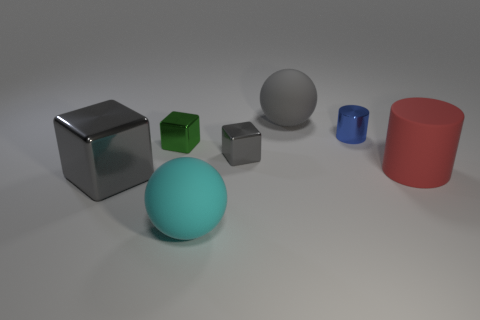Subtract all big cubes. How many cubes are left? 2 Subtract all red cylinders. How many gray cubes are left? 2 Add 2 large gray cubes. How many objects exist? 9 Subtract all green blocks. How many blocks are left? 2 Subtract all cubes. How many objects are left? 4 Subtract all small blue metallic objects. Subtract all small blue cylinders. How many objects are left? 5 Add 3 cyan things. How many cyan things are left? 4 Add 1 red objects. How many red objects exist? 2 Subtract 0 green balls. How many objects are left? 7 Subtract all purple spheres. Subtract all blue blocks. How many spheres are left? 2 